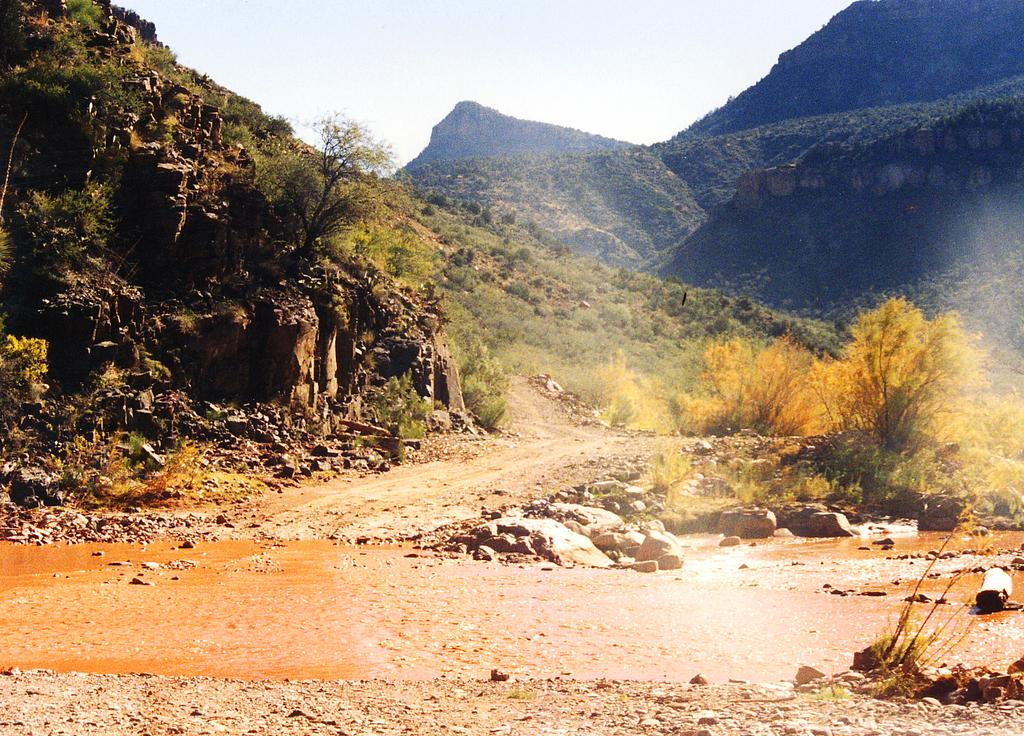What type of natural formation can be seen in the image? There are mountains in the image. What type of vegetation is present in the image? There is greenery in the image. What is visible at the bottom of the image? Land and water are visible at the bottom of the image. What part of the natural environment is visible at the top of the image? The sky is visible at the top of the image. Can you tell me how many light bulbs are hanging from the trees in the image? There are no light bulbs present in the image; it features mountains, greenery, land, water, and the sky. What type of card is being used by the farmer in the image? There is no farmer or card present in the image. 